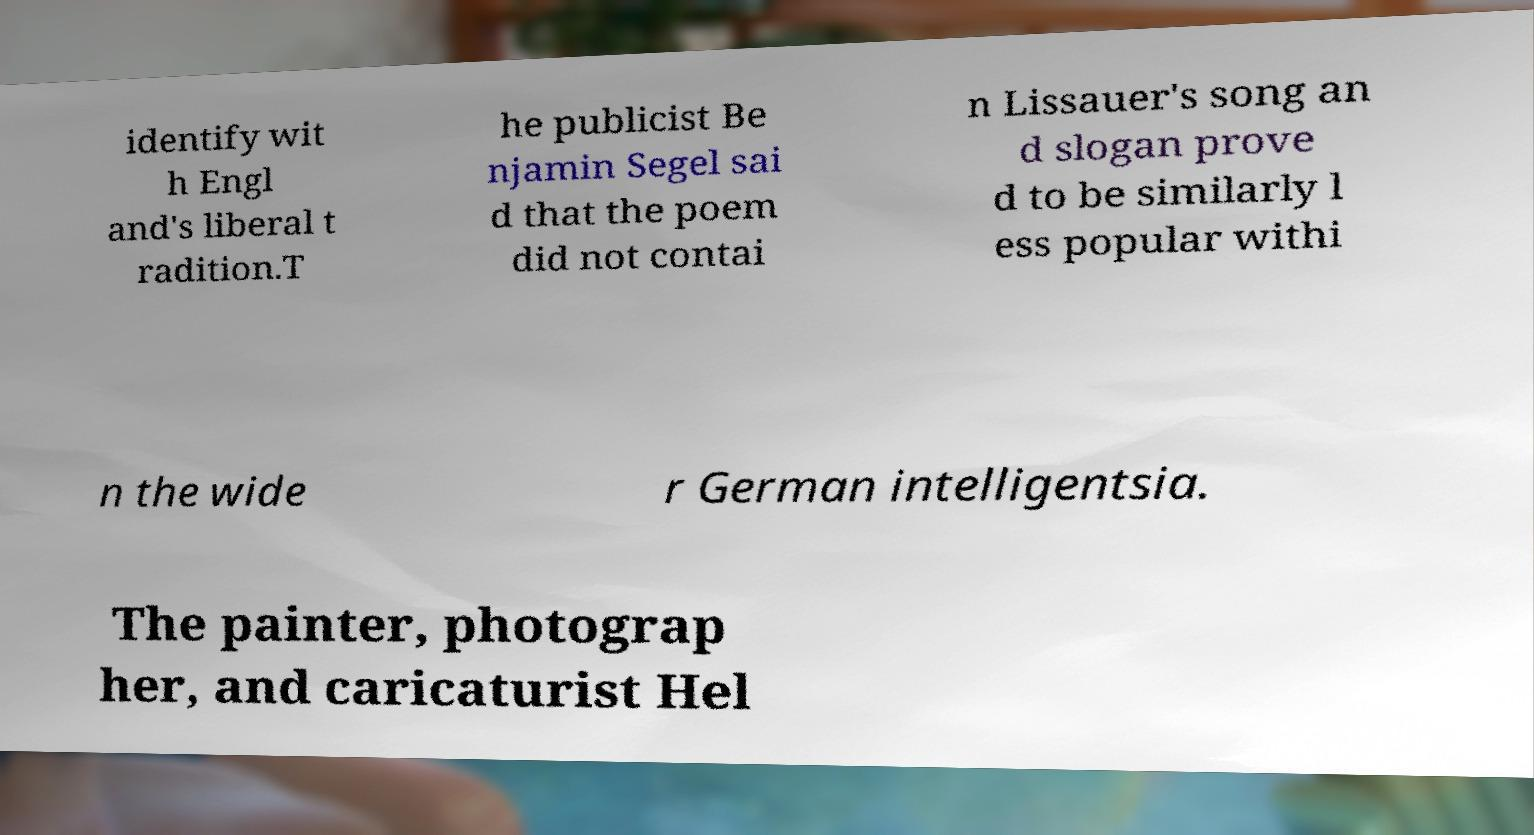There's text embedded in this image that I need extracted. Can you transcribe it verbatim? identify wit h Engl and's liberal t radition.T he publicist Be njamin Segel sai d that the poem did not contai n Lissauer's song an d slogan prove d to be similarly l ess popular withi n the wide r German intelligentsia. The painter, photograp her, and caricaturist Hel 